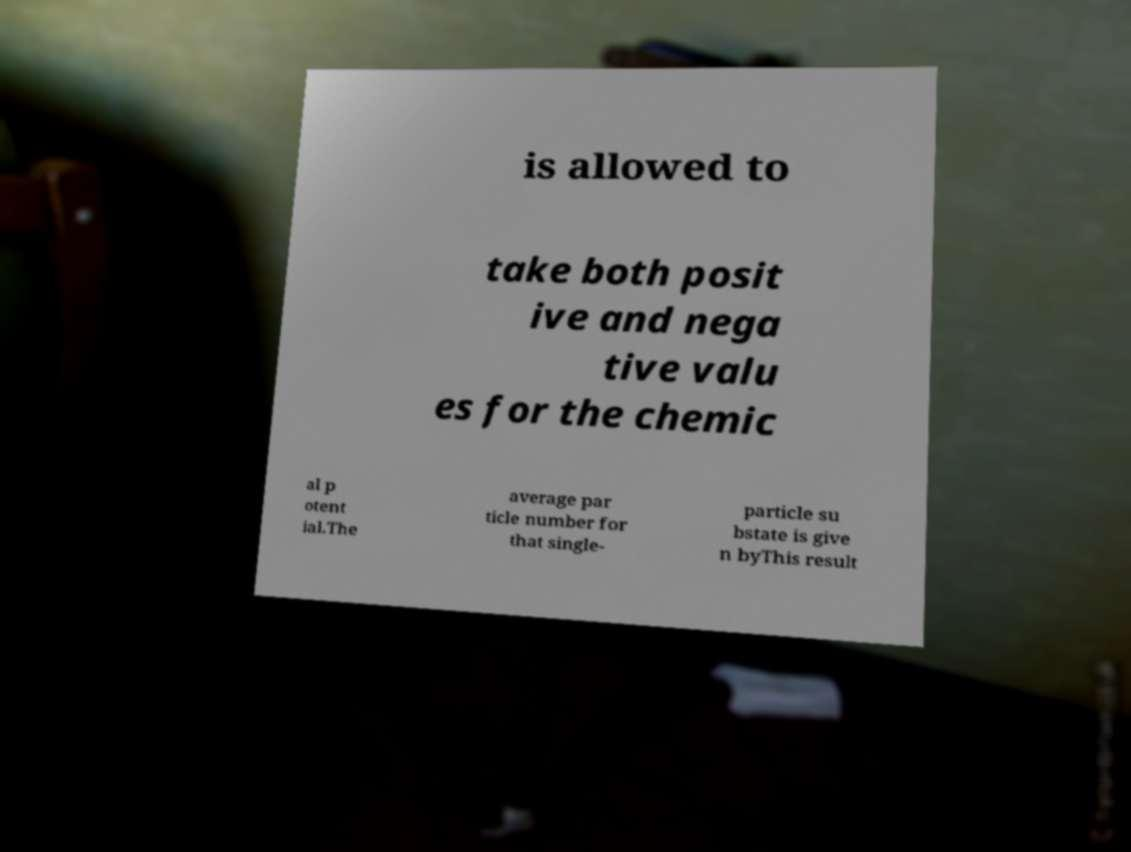What messages or text are displayed in this image? I need them in a readable, typed format. is allowed to take both posit ive and nega tive valu es for the chemic al p otent ial.The average par ticle number for that single- particle su bstate is give n byThis result 